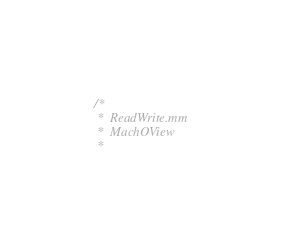<code> <loc_0><loc_0><loc_500><loc_500><_ObjectiveC_>/*
 *  ReadWrite.mm
 *  MachOView
 *</code> 